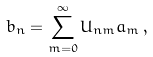<formula> <loc_0><loc_0><loc_500><loc_500>b _ { n } = \sum _ { m = 0 } ^ { \infty } U _ { n m } a _ { m } \, ,</formula> 